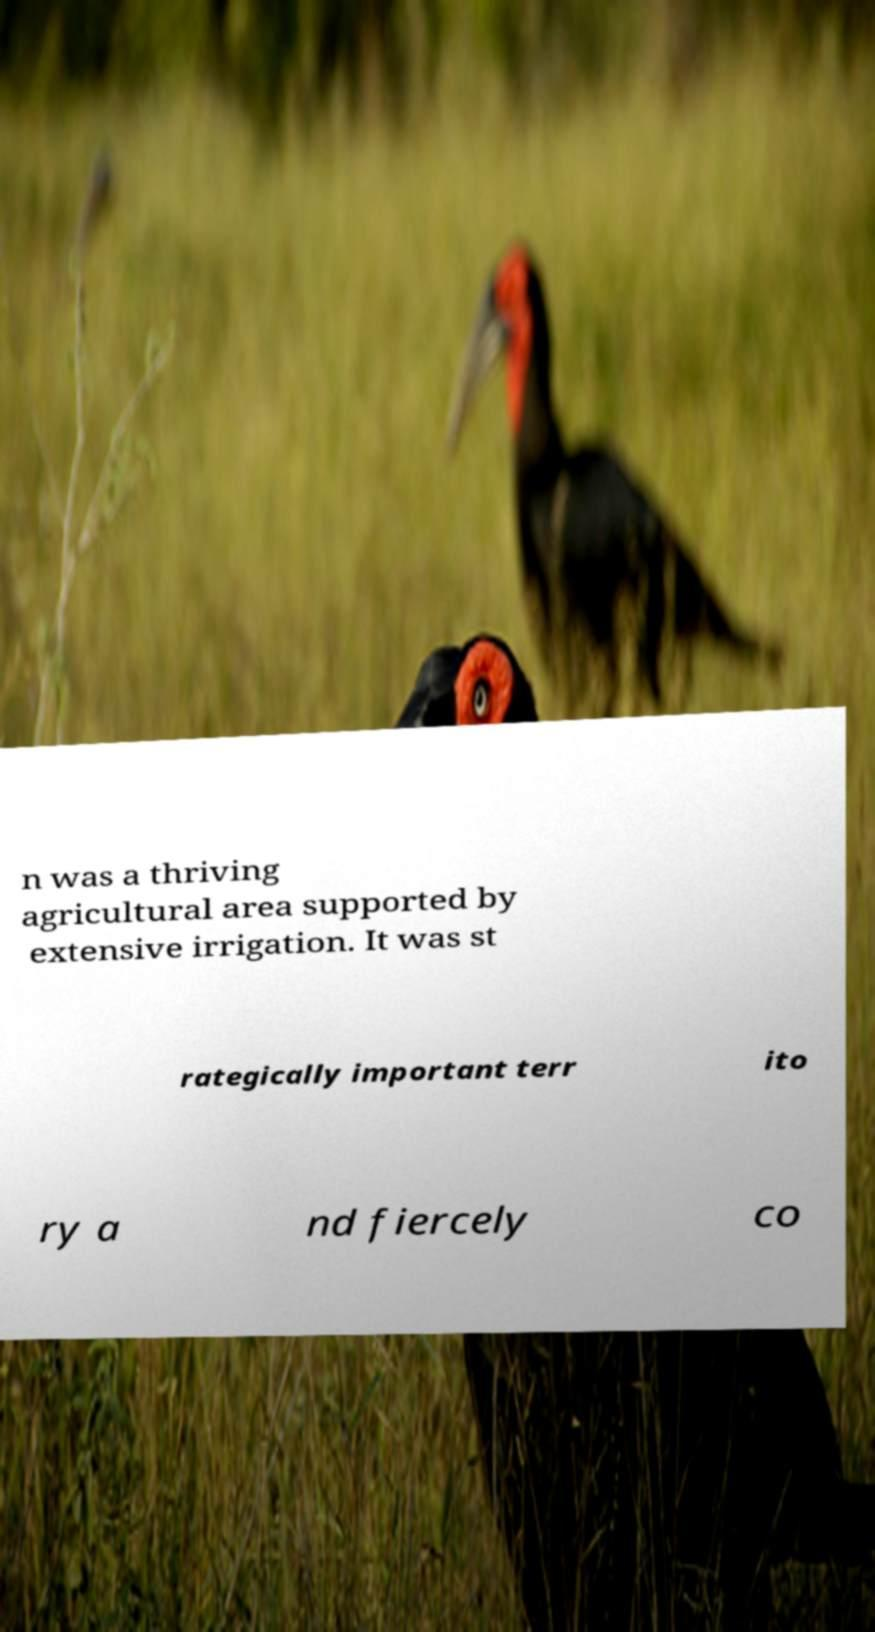Could you extract and type out the text from this image? n was a thriving agricultural area supported by extensive irrigation. It was st rategically important terr ito ry a nd fiercely co 